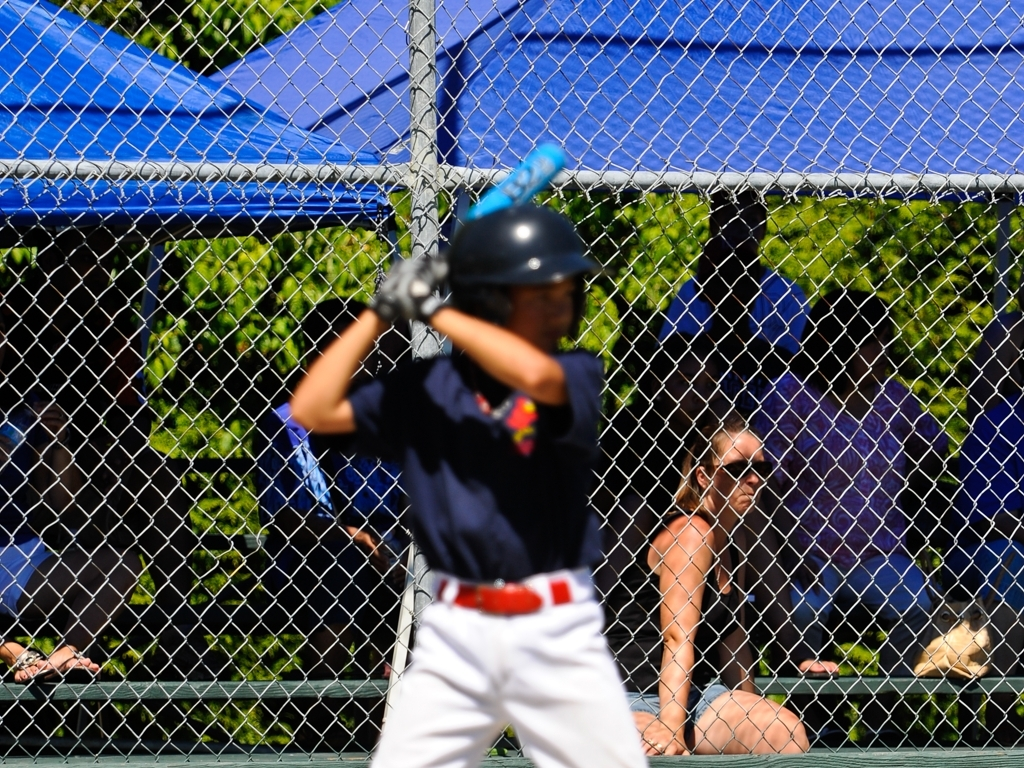What is the main activity captured in this image? The main activity appears to be a baseball game, with a particular focus on a batter who is ready to swing at an incoming pitch. Could you describe the atmosphere or setting of the game? The setting seems to be outdoors on a sunny day, possibly during a casual or amateur baseball game in a local park, suggested by the relaxed audience in the background and the presence of natural surroundings. 